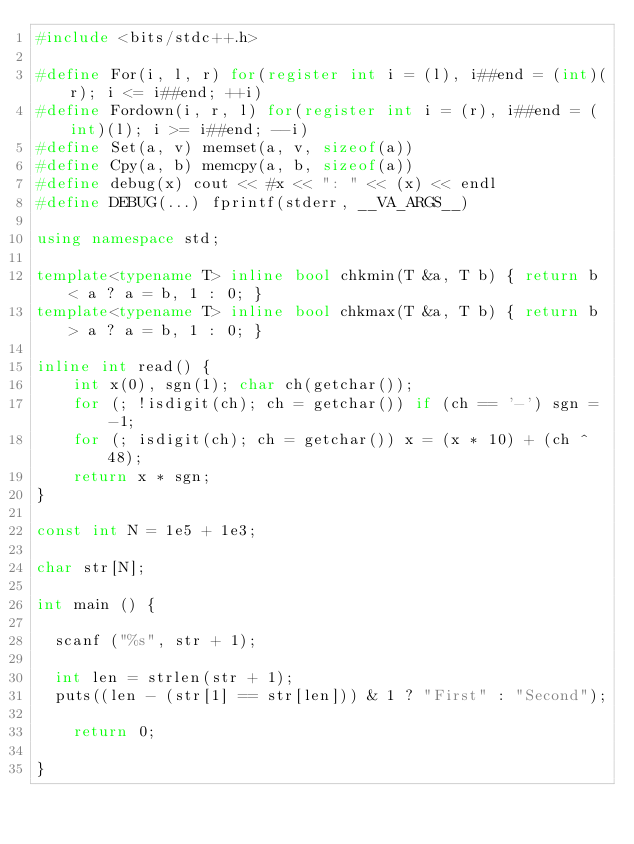Convert code to text. <code><loc_0><loc_0><loc_500><loc_500><_C++_>#include <bits/stdc++.h>

#define For(i, l, r) for(register int i = (l), i##end = (int)(r); i <= i##end; ++i)
#define Fordown(i, r, l) for(register int i = (r), i##end = (int)(l); i >= i##end; --i)
#define Set(a, v) memset(a, v, sizeof(a))
#define Cpy(a, b) memcpy(a, b, sizeof(a))
#define debug(x) cout << #x << ": " << (x) << endl
#define DEBUG(...) fprintf(stderr, __VA_ARGS__)

using namespace std;

template<typename T> inline bool chkmin(T &a, T b) { return b < a ? a = b, 1 : 0; }
template<typename T> inline bool chkmax(T &a, T b) { return b > a ? a = b, 1 : 0; }

inline int read() {
    int x(0), sgn(1); char ch(getchar());
    for (; !isdigit(ch); ch = getchar()) if (ch == '-') sgn = -1;
    for (; isdigit(ch); ch = getchar()) x = (x * 10) + (ch ^ 48);
    return x * sgn;
}

const int N = 1e5 + 1e3;

char str[N];

int main () {

	scanf ("%s", str + 1);

	int len = strlen(str + 1);
	puts((len - (str[1] == str[len])) & 1 ? "First" : "Second");

    return 0;

}
</code> 